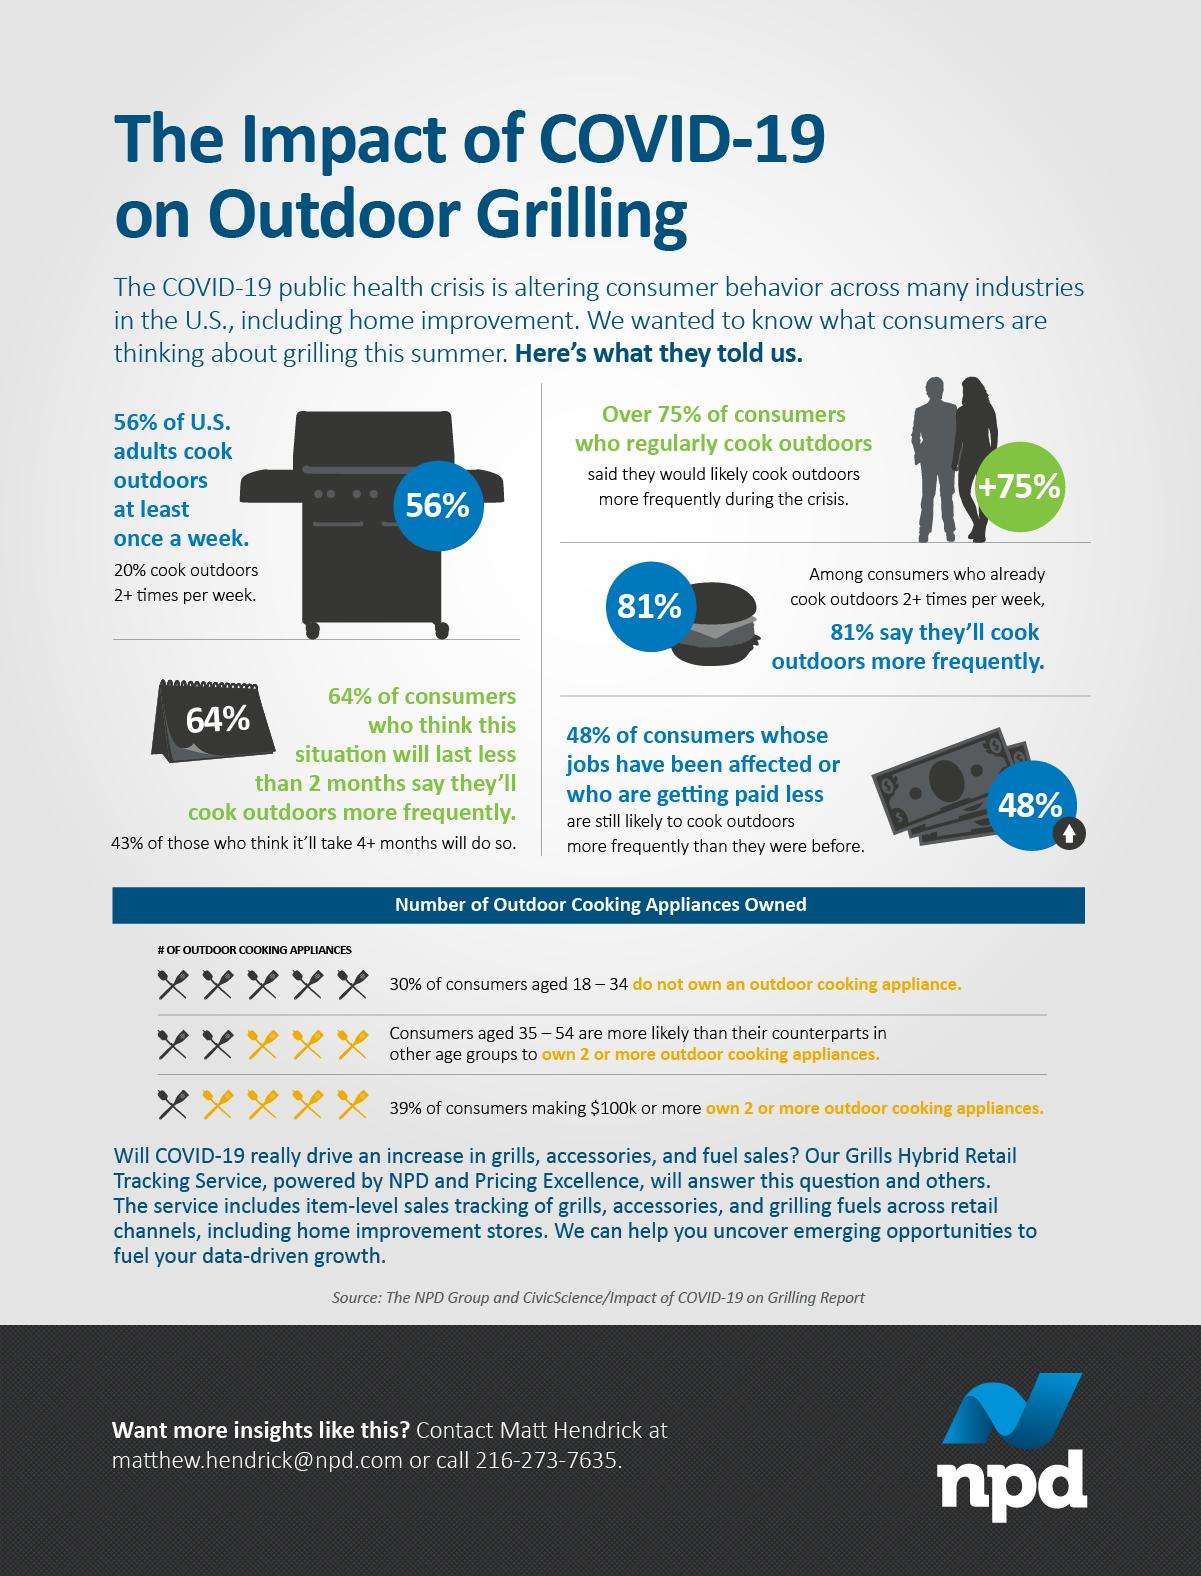Identify some key points in this picture. There are seven pairs of yellow spoons and forks that are visible in the photograph. In total, there are 15 pairs of spoons and forks shown. 